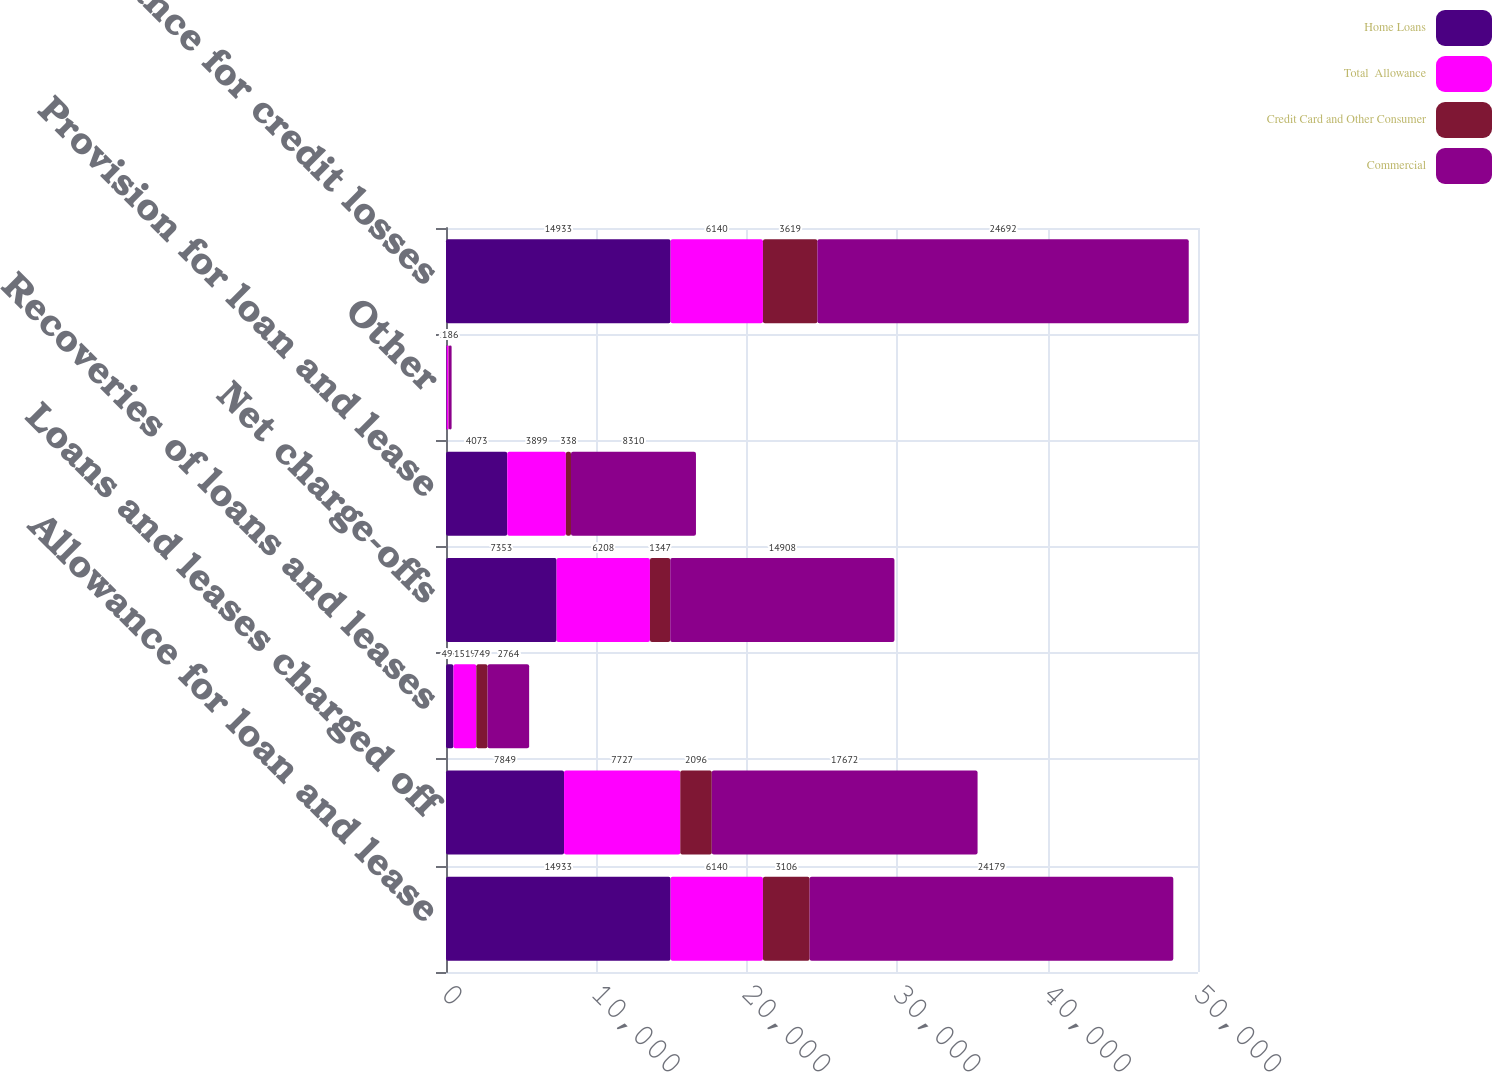Convert chart. <chart><loc_0><loc_0><loc_500><loc_500><stacked_bar_chart><ecel><fcel>Allowance for loan and lease<fcel>Loans and leases charged off<fcel>Recoveries of loans and leases<fcel>Net charge-offs<fcel>Provision for loan and lease<fcel>Other<fcel>Allowance for credit losses<nl><fcel>Home Loans<fcel>14933<fcel>7849<fcel>496<fcel>7353<fcel>4073<fcel>46<fcel>14933<nl><fcel>Total  Allowance<fcel>6140<fcel>7727<fcel>1519<fcel>6208<fcel>3899<fcel>120<fcel>6140<nl><fcel>Credit Card and Other Consumer<fcel>3106<fcel>2096<fcel>749<fcel>1347<fcel>338<fcel>20<fcel>3619<nl><fcel>Commercial<fcel>24179<fcel>17672<fcel>2764<fcel>14908<fcel>8310<fcel>186<fcel>24692<nl></chart> 